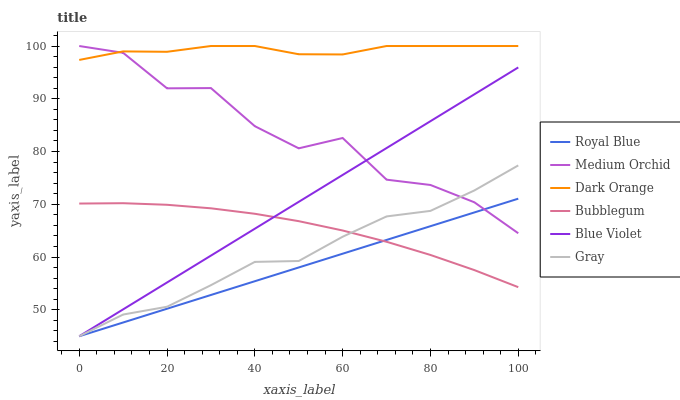Does Medium Orchid have the minimum area under the curve?
Answer yes or no. No. Does Medium Orchid have the maximum area under the curve?
Answer yes or no. No. Is Dark Orange the smoothest?
Answer yes or no. No. Is Dark Orange the roughest?
Answer yes or no. No. Does Medium Orchid have the lowest value?
Answer yes or no. No. Does Bubblegum have the highest value?
Answer yes or no. No. Is Royal Blue less than Dark Orange?
Answer yes or no. Yes. Is Dark Orange greater than Blue Violet?
Answer yes or no. Yes. Does Royal Blue intersect Dark Orange?
Answer yes or no. No. 